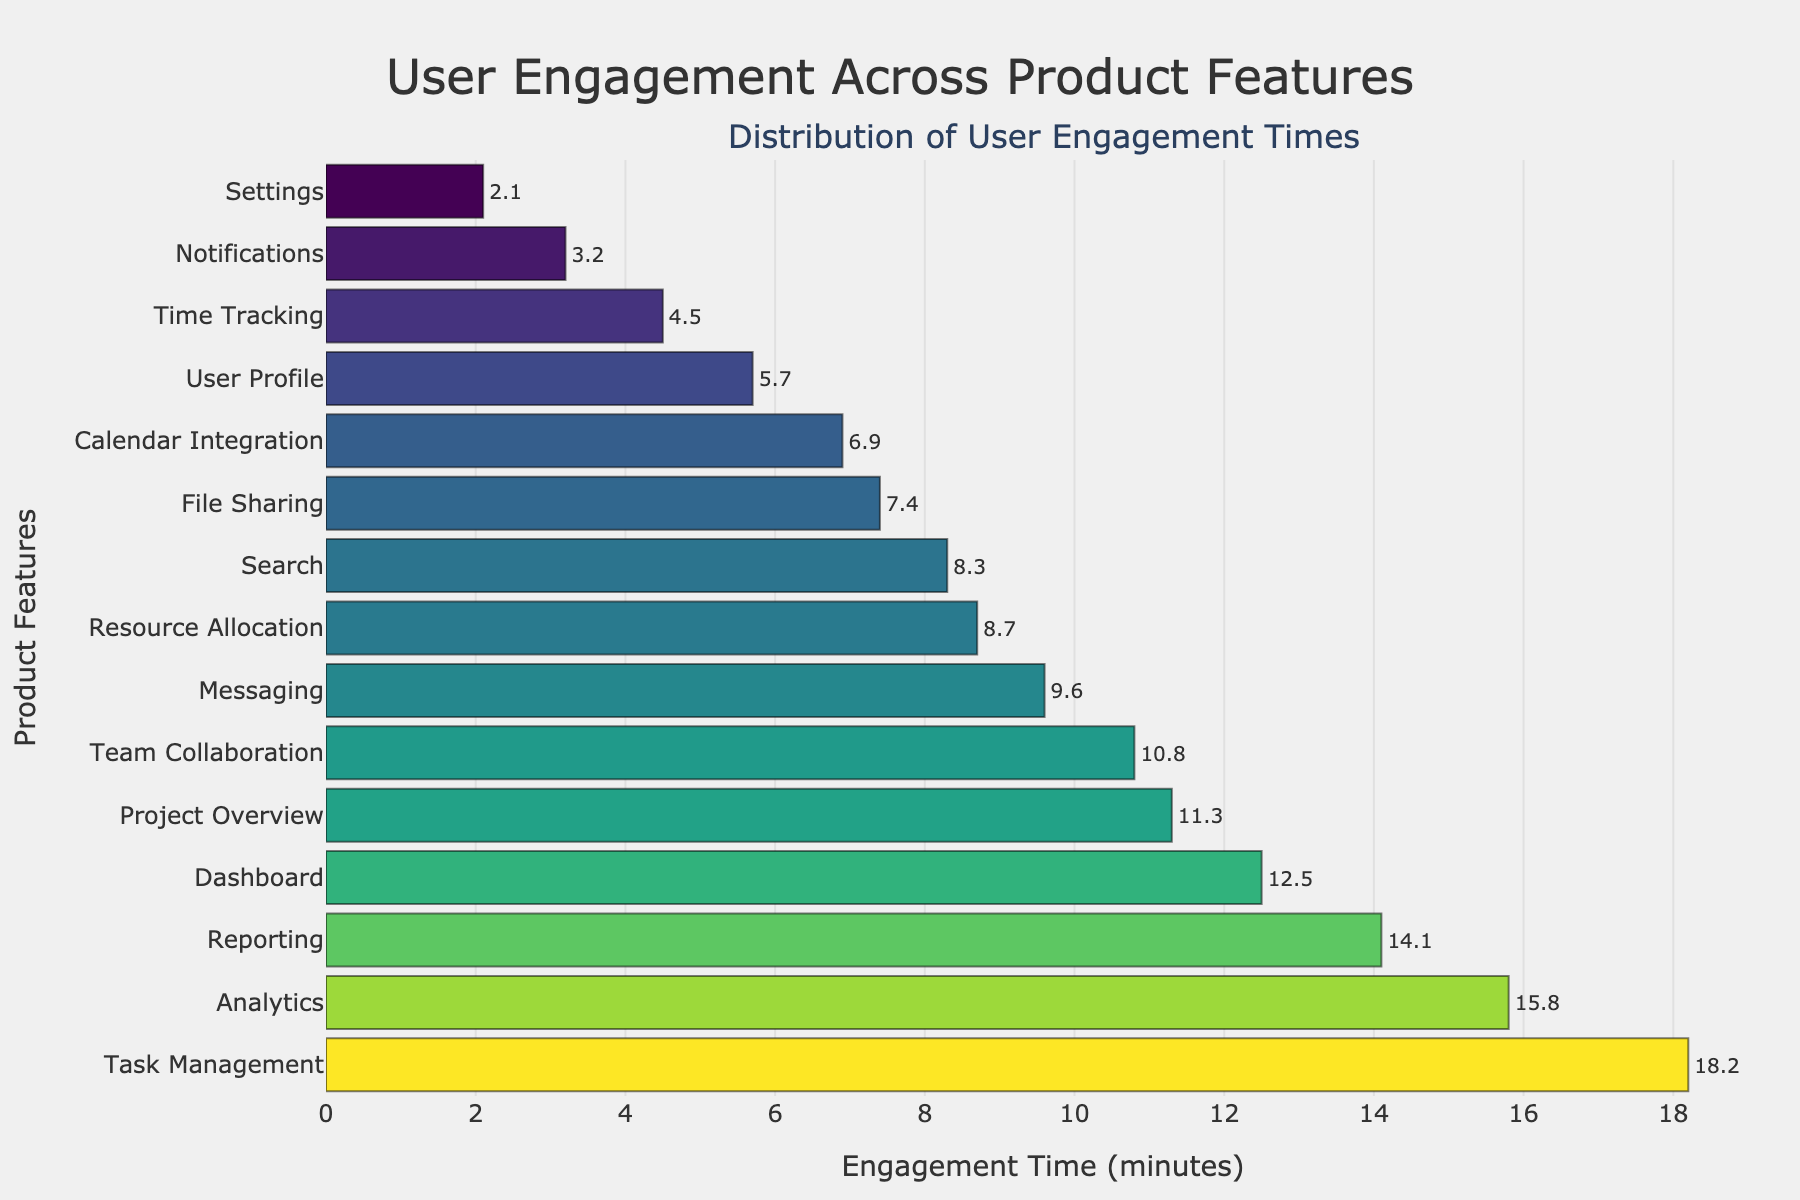What is the title of the figure? The title is usually provided at the top of the figure. From the generated code, it specifies the title of the plot.
Answer: User Engagement Across Product Features How many product features are displayed in the figure? Count the number of unique product features listed on the y-axis.
Answer: 15 Which product feature has the highest user engagement time? Look for the bar that extends the farthest to the right on the x-axis, representing the highest engagement time.
Answer: Task Management Which feature has the lowest engagement time and what is it? Identify the shortest bar on the x-axis, indicating the feature with the lowest engagement time.
Answer: Settings, 2.1 minutes What is the average engagement time across all product features? Sum all the engagement times and divide by the number of features. Sum = 12.5 + 8.3 + 5.7 + 3.2 + 15.8 + 2.1 + 9.6 + 18.2 + 6.9 + 7.4 + 14.1 + 11.3 + 10.8 + 8.7 + 4.5 = 139.1. Average = 139.1 / 15.
Answer: 9.27 minutes Which product features have engagement times greater than 10 minutes? Identify bars where the x values are greater than 10 minutes.
Answer: Dashboard, Analytics, Task Management, Reporting, Project Overview, Team Collaboration What is the difference in engagement time between 'Analytics' and 'Settings'? Subtract the engagement time of 'Settings' from that of 'Analytics'. Difference = 15.8 - 2.1
Answer: 13.7 minutes What percentage of features have engagement times below 5 minutes? Count the number of features with engagement times below 5 minutes and divide by the total number of features, then multiply by 100 to get the percentage. Count is 3 (Notifications, Settings, Time Tracking). Percentage = (3 / 15) * 100.
Answer: 20% How much more engagement time does 'Task Management' have compared to 'Reporting'? Subtract the engagement time of 'Reporting' from that of 'Task Management'. Difference = 18.2 - 14.1
Answer: 4.1 minutes Which two features have the closest engagement times? Identify the two bars whose lengths (engagement times) are the closest to each other.
Answer: Search and Resource Allocation (8.3 and 8.7) Is there a feature with exactly 10 minutes of engagement time? Check if any bar's x value is exactly 10 minutes.
Answer: No 